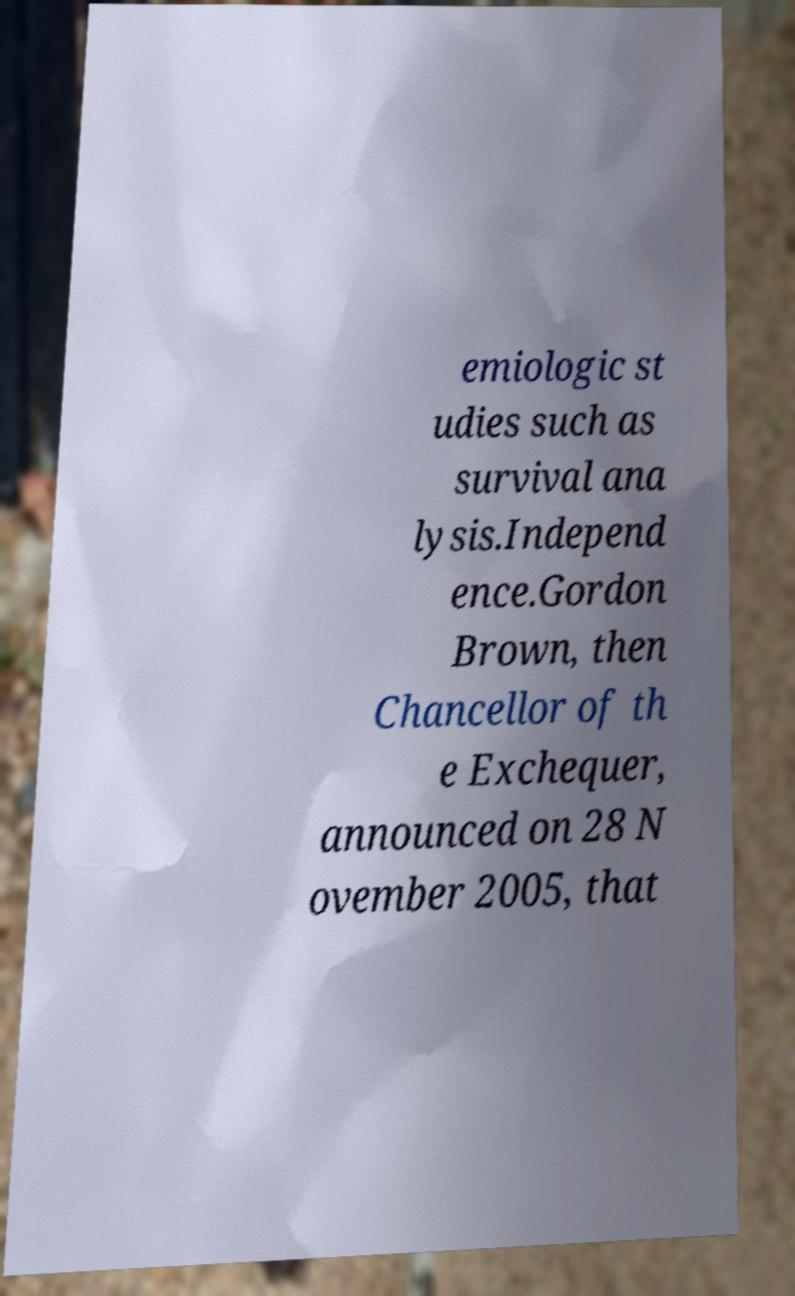Can you accurately transcribe the text from the provided image for me? emiologic st udies such as survival ana lysis.Independ ence.Gordon Brown, then Chancellor of th e Exchequer, announced on 28 N ovember 2005, that 